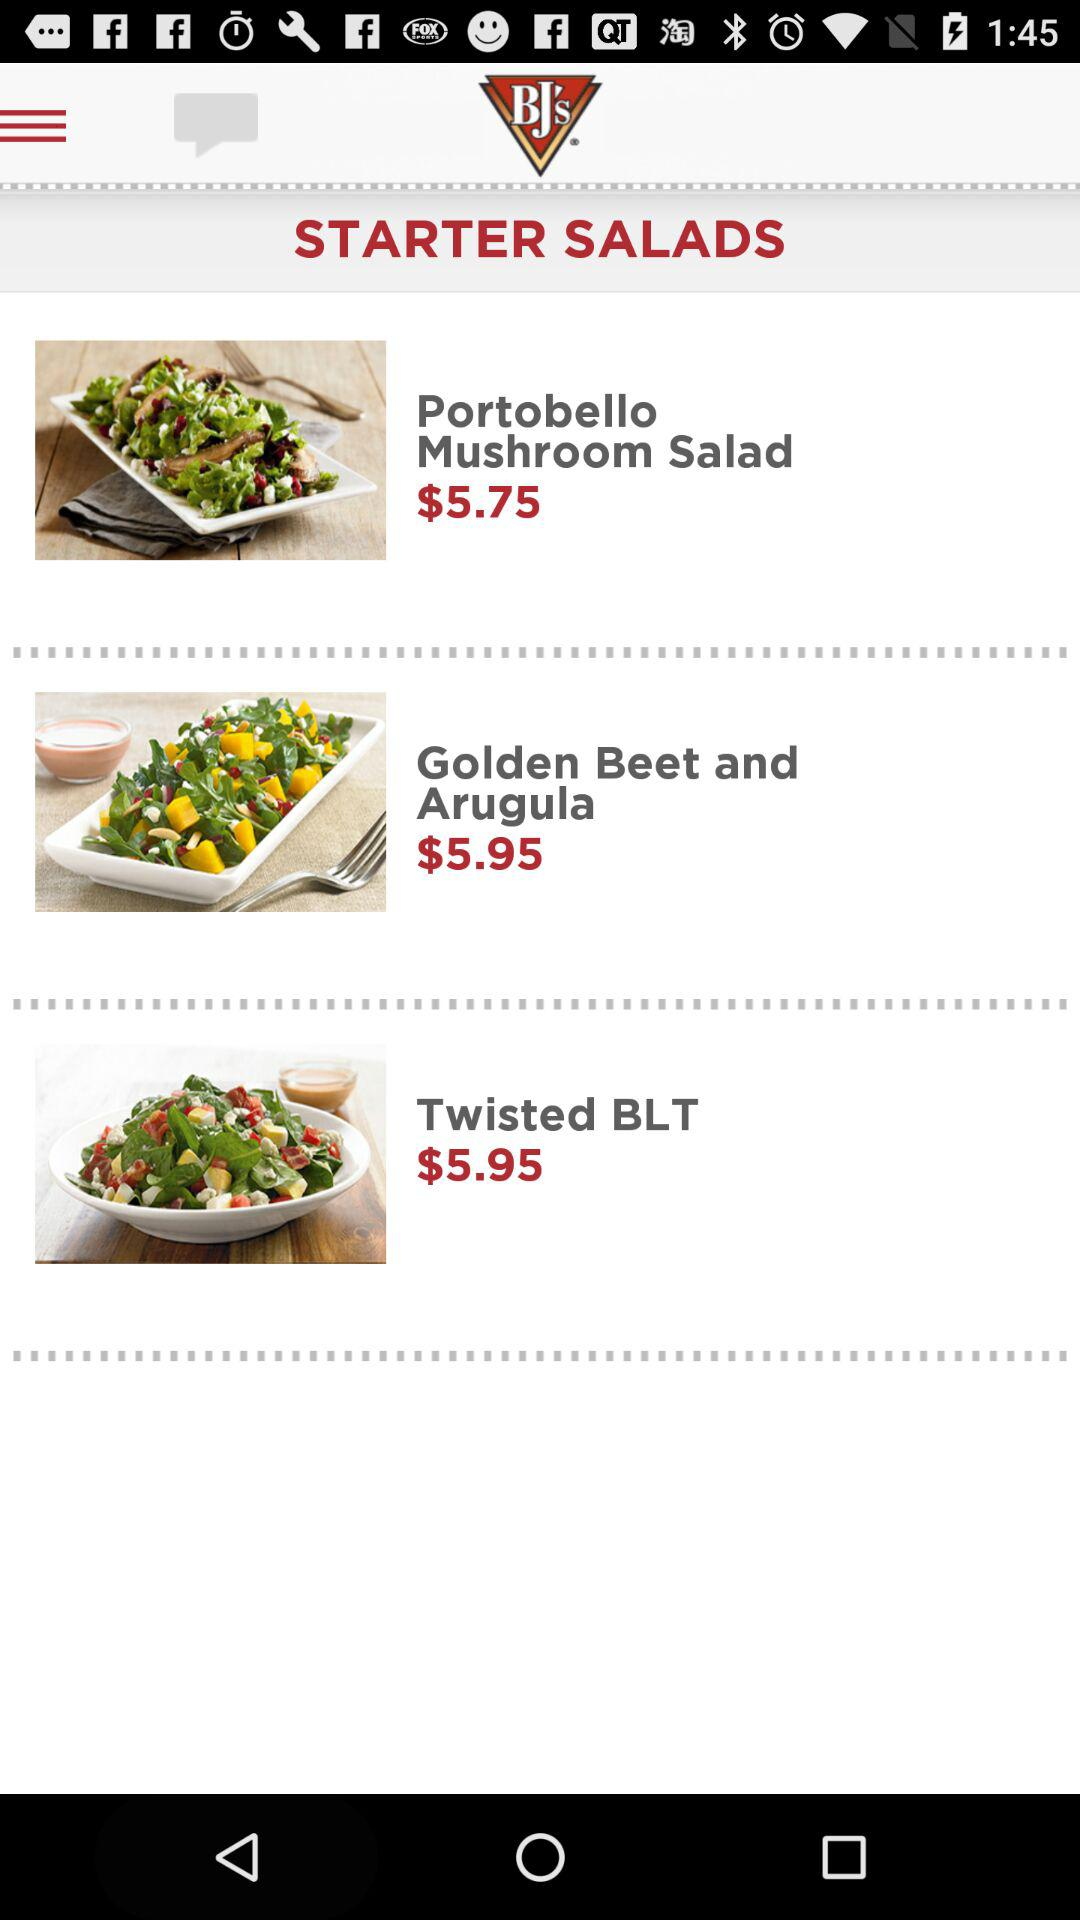Where is the nearest BJ's location?
When the provided information is insufficient, respond with <no answer>. <no answer> 